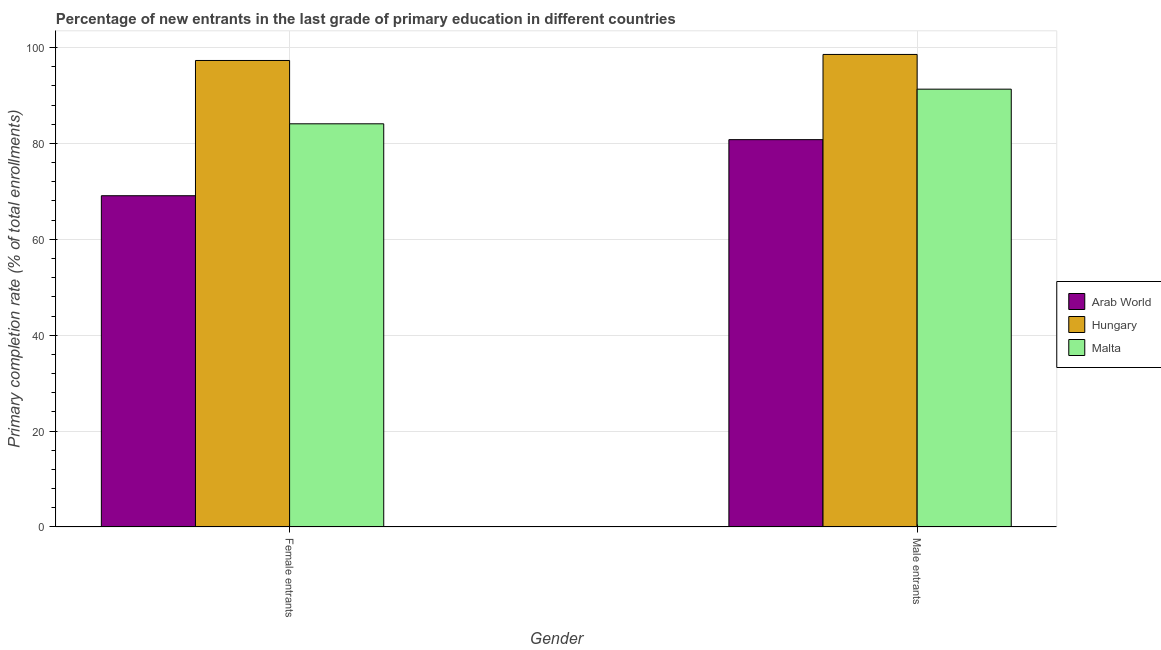How many different coloured bars are there?
Ensure brevity in your answer.  3. How many groups of bars are there?
Provide a succinct answer. 2. Are the number of bars on each tick of the X-axis equal?
Your response must be concise. Yes. How many bars are there on the 1st tick from the left?
Your answer should be very brief. 3. How many bars are there on the 1st tick from the right?
Provide a short and direct response. 3. What is the label of the 2nd group of bars from the left?
Give a very brief answer. Male entrants. What is the primary completion rate of female entrants in Arab World?
Offer a very short reply. 69.09. Across all countries, what is the maximum primary completion rate of male entrants?
Your answer should be very brief. 98.55. Across all countries, what is the minimum primary completion rate of male entrants?
Offer a terse response. 80.79. In which country was the primary completion rate of female entrants maximum?
Your answer should be very brief. Hungary. In which country was the primary completion rate of male entrants minimum?
Ensure brevity in your answer.  Arab World. What is the total primary completion rate of male entrants in the graph?
Offer a terse response. 270.65. What is the difference between the primary completion rate of male entrants in Hungary and that in Arab World?
Your answer should be compact. 17.77. What is the difference between the primary completion rate of male entrants in Arab World and the primary completion rate of female entrants in Hungary?
Give a very brief answer. -16.51. What is the average primary completion rate of female entrants per country?
Provide a succinct answer. 83.49. What is the difference between the primary completion rate of female entrants and primary completion rate of male entrants in Malta?
Provide a succinct answer. -7.23. In how many countries, is the primary completion rate of female entrants greater than 20 %?
Offer a very short reply. 3. What is the ratio of the primary completion rate of female entrants in Hungary to that in Arab World?
Offer a terse response. 1.41. Is the primary completion rate of male entrants in Arab World less than that in Malta?
Provide a short and direct response. Yes. In how many countries, is the primary completion rate of male entrants greater than the average primary completion rate of male entrants taken over all countries?
Offer a very short reply. 2. What does the 1st bar from the left in Female entrants represents?
Your answer should be very brief. Arab World. What does the 1st bar from the right in Male entrants represents?
Your response must be concise. Malta. Are all the bars in the graph horizontal?
Offer a very short reply. No. How many countries are there in the graph?
Ensure brevity in your answer.  3. Does the graph contain any zero values?
Your answer should be compact. No. Does the graph contain grids?
Offer a terse response. Yes. Where does the legend appear in the graph?
Provide a short and direct response. Center right. How many legend labels are there?
Provide a succinct answer. 3. What is the title of the graph?
Provide a short and direct response. Percentage of new entrants in the last grade of primary education in different countries. Does "Poland" appear as one of the legend labels in the graph?
Your response must be concise. No. What is the label or title of the X-axis?
Your answer should be very brief. Gender. What is the label or title of the Y-axis?
Offer a very short reply. Primary completion rate (% of total enrollments). What is the Primary completion rate (% of total enrollments) of Arab World in Female entrants?
Provide a succinct answer. 69.09. What is the Primary completion rate (% of total enrollments) in Hungary in Female entrants?
Make the answer very short. 97.3. What is the Primary completion rate (% of total enrollments) in Malta in Female entrants?
Your response must be concise. 84.09. What is the Primary completion rate (% of total enrollments) in Arab World in Male entrants?
Keep it short and to the point. 80.79. What is the Primary completion rate (% of total enrollments) in Hungary in Male entrants?
Give a very brief answer. 98.55. What is the Primary completion rate (% of total enrollments) of Malta in Male entrants?
Offer a very short reply. 91.31. Across all Gender, what is the maximum Primary completion rate (% of total enrollments) of Arab World?
Your response must be concise. 80.79. Across all Gender, what is the maximum Primary completion rate (% of total enrollments) of Hungary?
Keep it short and to the point. 98.55. Across all Gender, what is the maximum Primary completion rate (% of total enrollments) in Malta?
Your answer should be compact. 91.31. Across all Gender, what is the minimum Primary completion rate (% of total enrollments) in Arab World?
Make the answer very short. 69.09. Across all Gender, what is the minimum Primary completion rate (% of total enrollments) of Hungary?
Your response must be concise. 97.3. Across all Gender, what is the minimum Primary completion rate (% of total enrollments) of Malta?
Offer a terse response. 84.09. What is the total Primary completion rate (% of total enrollments) in Arab World in the graph?
Make the answer very short. 149.88. What is the total Primary completion rate (% of total enrollments) of Hungary in the graph?
Make the answer very short. 195.85. What is the total Primary completion rate (% of total enrollments) in Malta in the graph?
Give a very brief answer. 175.4. What is the difference between the Primary completion rate (% of total enrollments) of Arab World in Female entrants and that in Male entrants?
Ensure brevity in your answer.  -11.69. What is the difference between the Primary completion rate (% of total enrollments) of Hungary in Female entrants and that in Male entrants?
Keep it short and to the point. -1.26. What is the difference between the Primary completion rate (% of total enrollments) in Malta in Female entrants and that in Male entrants?
Your response must be concise. -7.23. What is the difference between the Primary completion rate (% of total enrollments) of Arab World in Female entrants and the Primary completion rate (% of total enrollments) of Hungary in Male entrants?
Your answer should be compact. -29.46. What is the difference between the Primary completion rate (% of total enrollments) in Arab World in Female entrants and the Primary completion rate (% of total enrollments) in Malta in Male entrants?
Offer a terse response. -22.22. What is the difference between the Primary completion rate (% of total enrollments) of Hungary in Female entrants and the Primary completion rate (% of total enrollments) of Malta in Male entrants?
Provide a succinct answer. 5.98. What is the average Primary completion rate (% of total enrollments) in Arab World per Gender?
Make the answer very short. 74.94. What is the average Primary completion rate (% of total enrollments) in Hungary per Gender?
Your answer should be very brief. 97.93. What is the average Primary completion rate (% of total enrollments) in Malta per Gender?
Give a very brief answer. 87.7. What is the difference between the Primary completion rate (% of total enrollments) of Arab World and Primary completion rate (% of total enrollments) of Hungary in Female entrants?
Your response must be concise. -28.21. What is the difference between the Primary completion rate (% of total enrollments) in Arab World and Primary completion rate (% of total enrollments) in Malta in Female entrants?
Provide a succinct answer. -15. What is the difference between the Primary completion rate (% of total enrollments) of Hungary and Primary completion rate (% of total enrollments) of Malta in Female entrants?
Provide a short and direct response. 13.21. What is the difference between the Primary completion rate (% of total enrollments) of Arab World and Primary completion rate (% of total enrollments) of Hungary in Male entrants?
Give a very brief answer. -17.77. What is the difference between the Primary completion rate (% of total enrollments) of Arab World and Primary completion rate (% of total enrollments) of Malta in Male entrants?
Your answer should be compact. -10.53. What is the difference between the Primary completion rate (% of total enrollments) in Hungary and Primary completion rate (% of total enrollments) in Malta in Male entrants?
Keep it short and to the point. 7.24. What is the ratio of the Primary completion rate (% of total enrollments) in Arab World in Female entrants to that in Male entrants?
Give a very brief answer. 0.86. What is the ratio of the Primary completion rate (% of total enrollments) of Hungary in Female entrants to that in Male entrants?
Your answer should be very brief. 0.99. What is the ratio of the Primary completion rate (% of total enrollments) in Malta in Female entrants to that in Male entrants?
Offer a terse response. 0.92. What is the difference between the highest and the second highest Primary completion rate (% of total enrollments) in Arab World?
Ensure brevity in your answer.  11.69. What is the difference between the highest and the second highest Primary completion rate (% of total enrollments) in Hungary?
Offer a terse response. 1.26. What is the difference between the highest and the second highest Primary completion rate (% of total enrollments) of Malta?
Provide a short and direct response. 7.23. What is the difference between the highest and the lowest Primary completion rate (% of total enrollments) of Arab World?
Ensure brevity in your answer.  11.69. What is the difference between the highest and the lowest Primary completion rate (% of total enrollments) in Hungary?
Make the answer very short. 1.26. What is the difference between the highest and the lowest Primary completion rate (% of total enrollments) of Malta?
Make the answer very short. 7.23. 